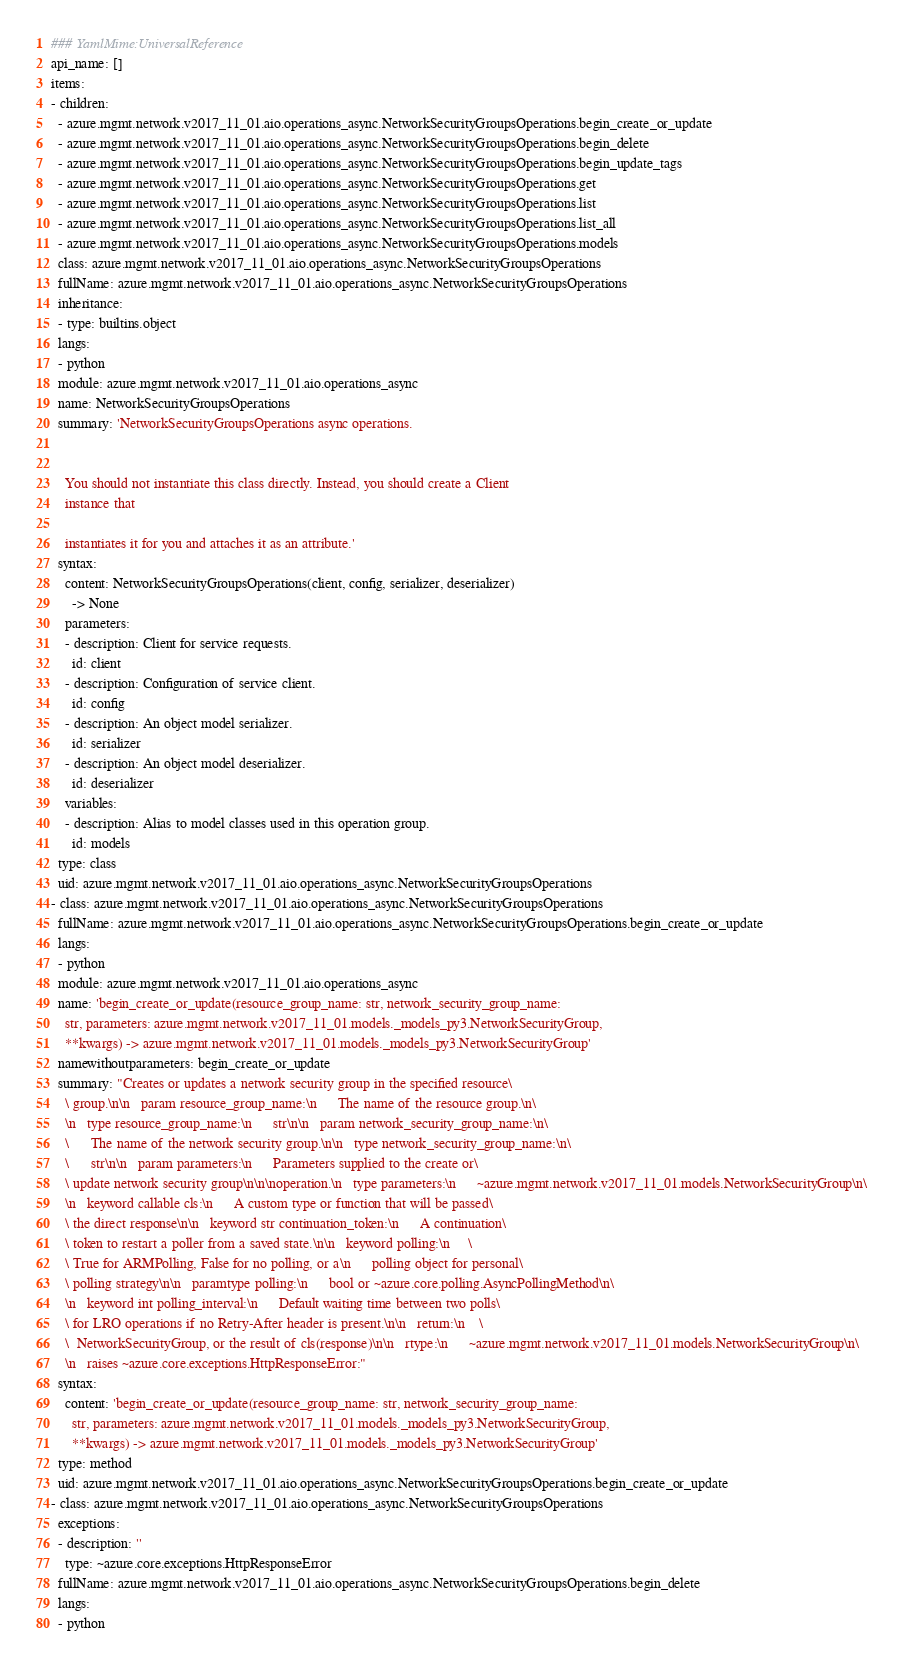Convert code to text. <code><loc_0><loc_0><loc_500><loc_500><_YAML_>### YamlMime:UniversalReference
api_name: []
items:
- children:
  - azure.mgmt.network.v2017_11_01.aio.operations_async.NetworkSecurityGroupsOperations.begin_create_or_update
  - azure.mgmt.network.v2017_11_01.aio.operations_async.NetworkSecurityGroupsOperations.begin_delete
  - azure.mgmt.network.v2017_11_01.aio.operations_async.NetworkSecurityGroupsOperations.begin_update_tags
  - azure.mgmt.network.v2017_11_01.aio.operations_async.NetworkSecurityGroupsOperations.get
  - azure.mgmt.network.v2017_11_01.aio.operations_async.NetworkSecurityGroupsOperations.list
  - azure.mgmt.network.v2017_11_01.aio.operations_async.NetworkSecurityGroupsOperations.list_all
  - azure.mgmt.network.v2017_11_01.aio.operations_async.NetworkSecurityGroupsOperations.models
  class: azure.mgmt.network.v2017_11_01.aio.operations_async.NetworkSecurityGroupsOperations
  fullName: azure.mgmt.network.v2017_11_01.aio.operations_async.NetworkSecurityGroupsOperations
  inheritance:
  - type: builtins.object
  langs:
  - python
  module: azure.mgmt.network.v2017_11_01.aio.operations_async
  name: NetworkSecurityGroupsOperations
  summary: 'NetworkSecurityGroupsOperations async operations.


    You should not instantiate this class directly. Instead, you should create a Client
    instance that

    instantiates it for you and attaches it as an attribute.'
  syntax:
    content: NetworkSecurityGroupsOperations(client, config, serializer, deserializer)
      -> None
    parameters:
    - description: Client for service requests.
      id: client
    - description: Configuration of service client.
      id: config
    - description: An object model serializer.
      id: serializer
    - description: An object model deserializer.
      id: deserializer
    variables:
    - description: Alias to model classes used in this operation group.
      id: models
  type: class
  uid: azure.mgmt.network.v2017_11_01.aio.operations_async.NetworkSecurityGroupsOperations
- class: azure.mgmt.network.v2017_11_01.aio.operations_async.NetworkSecurityGroupsOperations
  fullName: azure.mgmt.network.v2017_11_01.aio.operations_async.NetworkSecurityGroupsOperations.begin_create_or_update
  langs:
  - python
  module: azure.mgmt.network.v2017_11_01.aio.operations_async
  name: 'begin_create_or_update(resource_group_name: str, network_security_group_name:
    str, parameters: azure.mgmt.network.v2017_11_01.models._models_py3.NetworkSecurityGroup,
    **kwargs) -> azure.mgmt.network.v2017_11_01.models._models_py3.NetworkSecurityGroup'
  namewithoutparameters: begin_create_or_update
  summary: "Creates or updates a network security group in the specified resource\
    \ group.\n\n   param resource_group_name:\n      The name of the resource group.\n\
    \n   type resource_group_name:\n      str\n\n   param network_security_group_name:\n\
    \      The name of the network security group.\n\n   type network_security_group_name:\n\
    \      str\n\n   param parameters:\n      Parameters supplied to the create or\
    \ update network security group\n\n\noperation.\n   type parameters:\n      ~azure.mgmt.network.v2017_11_01.models.NetworkSecurityGroup\n\
    \n   keyword callable cls:\n      A custom type or function that will be passed\
    \ the direct response\n\n   keyword str continuation_token:\n      A continuation\
    \ token to restart a poller from a saved state.\n\n   keyword polling:\n     \
    \ True for ARMPolling, False for no polling, or a\n      polling object for personal\
    \ polling strategy\n\n   paramtype polling:\n      bool or ~azure.core.polling.AsyncPollingMethod\n\
    \n   keyword int polling_interval:\n      Default waiting time between two polls\
    \ for LRO operations if no Retry-After header is present.\n\n   return:\n    \
    \  NetworkSecurityGroup, or the result of cls(response)\n\n   rtype:\n      ~azure.mgmt.network.v2017_11_01.models.NetworkSecurityGroup\n\
    \n   raises ~azure.core.exceptions.HttpResponseError:"
  syntax:
    content: 'begin_create_or_update(resource_group_name: str, network_security_group_name:
      str, parameters: azure.mgmt.network.v2017_11_01.models._models_py3.NetworkSecurityGroup,
      **kwargs) -> azure.mgmt.network.v2017_11_01.models._models_py3.NetworkSecurityGroup'
  type: method
  uid: azure.mgmt.network.v2017_11_01.aio.operations_async.NetworkSecurityGroupsOperations.begin_create_or_update
- class: azure.mgmt.network.v2017_11_01.aio.operations_async.NetworkSecurityGroupsOperations
  exceptions:
  - description: ''
    type: ~azure.core.exceptions.HttpResponseError
  fullName: azure.mgmt.network.v2017_11_01.aio.operations_async.NetworkSecurityGroupsOperations.begin_delete
  langs:
  - python</code> 